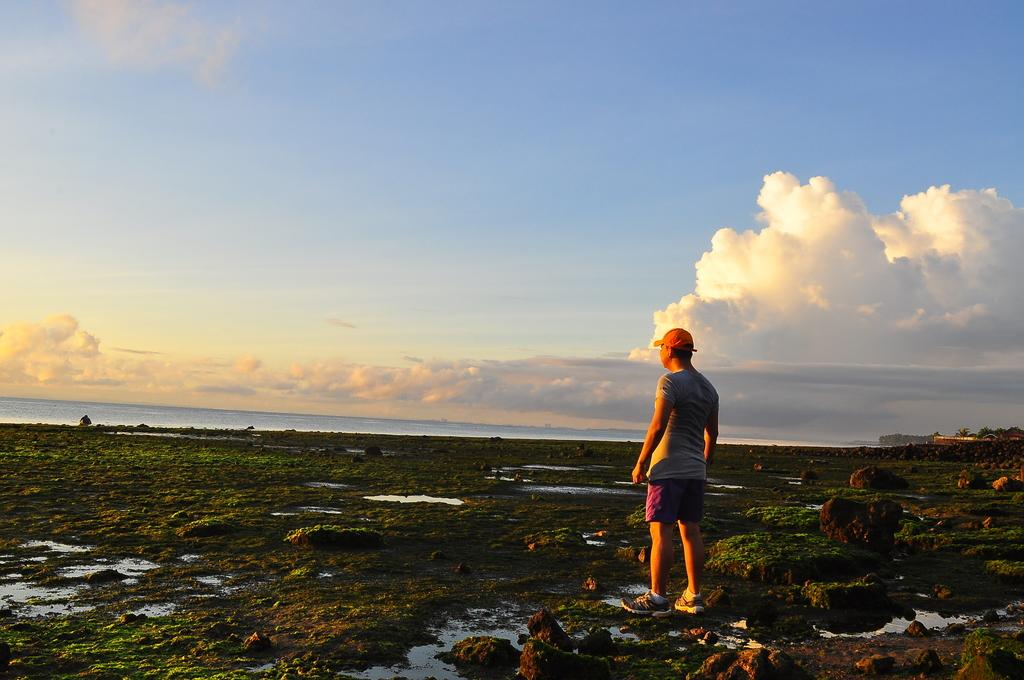What is the main subject of the image? There is a person standing in the image. What type of terrain is visible in the image? There are stones visible in the image. What natural element is present in the image? There is water in the image. What can be seen in the distance in the image? The background of the image includes a sea. What is the condition of the sky in the image? The sky is cloudy and visible at the top of the image. What type of religious competition is taking place in the image? There is no religious competition present in the image. What type of plane can be seen flying in the image? There is no plane visible in the image. 